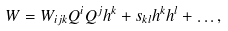Convert formula to latex. <formula><loc_0><loc_0><loc_500><loc_500>W = W _ { i j k } Q ^ { i } Q ^ { j } h ^ { k } + s _ { k l } h ^ { k } h ^ { l } + \dots ,</formula> 